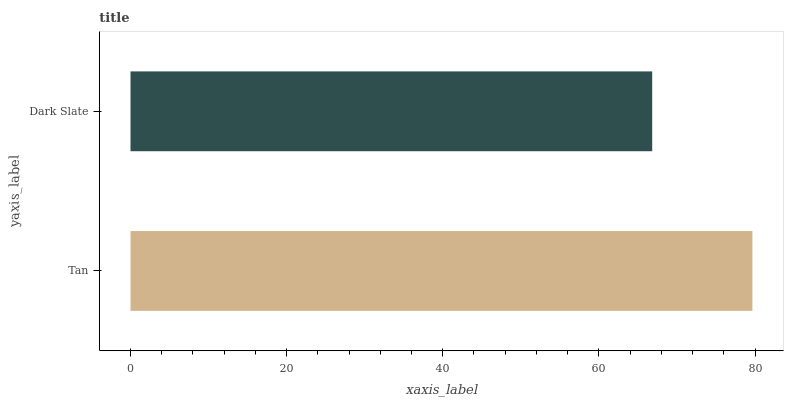Is Dark Slate the minimum?
Answer yes or no. Yes. Is Tan the maximum?
Answer yes or no. Yes. Is Dark Slate the maximum?
Answer yes or no. No. Is Tan greater than Dark Slate?
Answer yes or no. Yes. Is Dark Slate less than Tan?
Answer yes or no. Yes. Is Dark Slate greater than Tan?
Answer yes or no. No. Is Tan less than Dark Slate?
Answer yes or no. No. Is Tan the high median?
Answer yes or no. Yes. Is Dark Slate the low median?
Answer yes or no. Yes. Is Dark Slate the high median?
Answer yes or no. No. Is Tan the low median?
Answer yes or no. No. 